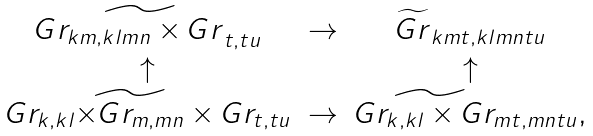<formula> <loc_0><loc_0><loc_500><loc_500>\begin{array} { c c c } G \widetilde { r _ { k m , k l m n } \times G r } _ { t , t u } & \rightarrow & \widetilde { G r } _ { k m t , k l m n t u } \\ \uparrow & & \uparrow \\ G r _ { k , k l } \widetilde { \times G r _ { m , m n } } \times G r _ { t , t u } & \rightarrow & G \widetilde { r _ { k , k l } \times G } r _ { m t , m n t u } , \end{array}</formula> 